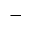Convert formula to latex. <formula><loc_0><loc_0><loc_500><loc_500>-</formula> 